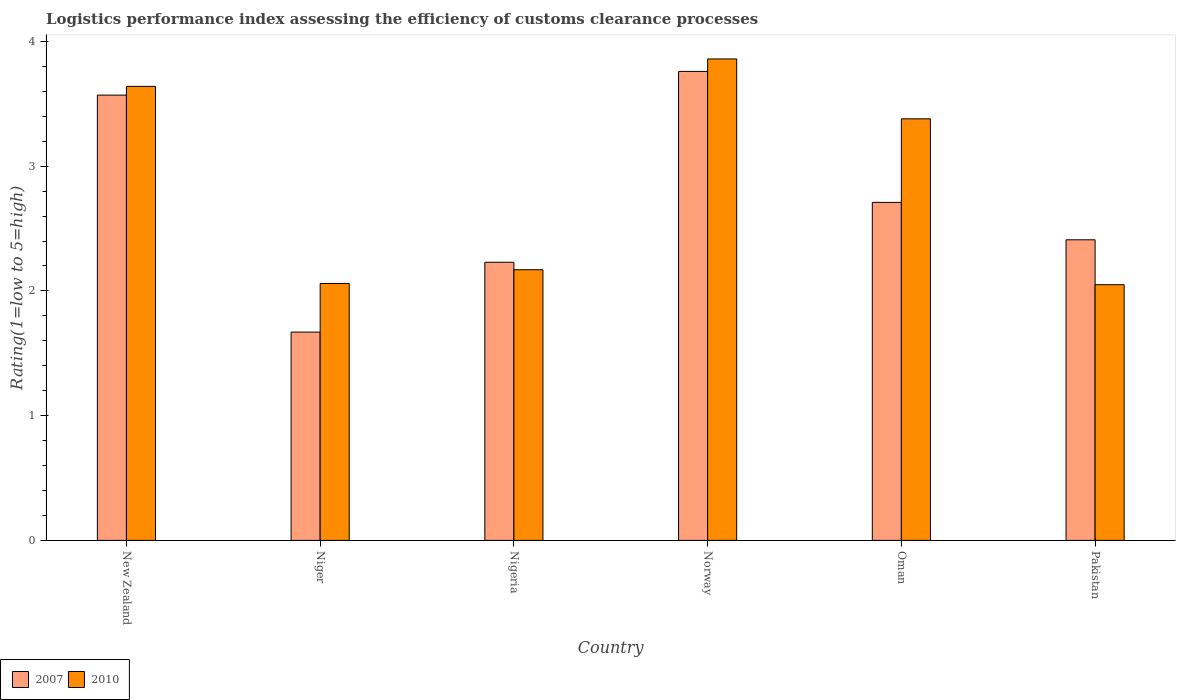How many different coloured bars are there?
Your response must be concise. 2. How many groups of bars are there?
Your answer should be compact. 6. Are the number of bars on each tick of the X-axis equal?
Your answer should be very brief. Yes. How many bars are there on the 3rd tick from the left?
Offer a terse response. 2. What is the Logistic performance index in 2010 in Norway?
Ensure brevity in your answer.  3.86. Across all countries, what is the maximum Logistic performance index in 2010?
Provide a succinct answer. 3.86. Across all countries, what is the minimum Logistic performance index in 2010?
Make the answer very short. 2.05. In which country was the Logistic performance index in 2010 minimum?
Offer a very short reply. Pakistan. What is the total Logistic performance index in 2010 in the graph?
Your response must be concise. 17.16. What is the difference between the Logistic performance index in 2007 in Norway and that in Oman?
Your answer should be compact. 1.05. What is the difference between the Logistic performance index in 2010 in Oman and the Logistic performance index in 2007 in Niger?
Provide a succinct answer. 1.71. What is the average Logistic performance index in 2010 per country?
Ensure brevity in your answer.  2.86. What is the difference between the Logistic performance index of/in 2010 and Logistic performance index of/in 2007 in Pakistan?
Your response must be concise. -0.36. What is the ratio of the Logistic performance index in 2010 in Norway to that in Oman?
Keep it short and to the point. 1.14. Is the Logistic performance index in 2007 in New Zealand less than that in Nigeria?
Offer a terse response. No. Is the difference between the Logistic performance index in 2010 in Oman and Pakistan greater than the difference between the Logistic performance index in 2007 in Oman and Pakistan?
Keep it short and to the point. Yes. What is the difference between the highest and the second highest Logistic performance index in 2010?
Give a very brief answer. -0.22. What is the difference between the highest and the lowest Logistic performance index in 2007?
Your response must be concise. 2.09. In how many countries, is the Logistic performance index in 2010 greater than the average Logistic performance index in 2010 taken over all countries?
Your response must be concise. 3. Is the sum of the Logistic performance index in 2010 in Niger and Oman greater than the maximum Logistic performance index in 2007 across all countries?
Make the answer very short. Yes. How many countries are there in the graph?
Provide a short and direct response. 6. What is the difference between two consecutive major ticks on the Y-axis?
Make the answer very short. 1. Are the values on the major ticks of Y-axis written in scientific E-notation?
Offer a very short reply. No. Does the graph contain any zero values?
Give a very brief answer. No. Does the graph contain grids?
Ensure brevity in your answer.  No. Where does the legend appear in the graph?
Make the answer very short. Bottom left. How many legend labels are there?
Make the answer very short. 2. How are the legend labels stacked?
Make the answer very short. Horizontal. What is the title of the graph?
Provide a succinct answer. Logistics performance index assessing the efficiency of customs clearance processes. Does "2009" appear as one of the legend labels in the graph?
Your response must be concise. No. What is the label or title of the Y-axis?
Give a very brief answer. Rating(1=low to 5=high). What is the Rating(1=low to 5=high) in 2007 in New Zealand?
Offer a very short reply. 3.57. What is the Rating(1=low to 5=high) of 2010 in New Zealand?
Keep it short and to the point. 3.64. What is the Rating(1=low to 5=high) in 2007 in Niger?
Give a very brief answer. 1.67. What is the Rating(1=low to 5=high) of 2010 in Niger?
Provide a short and direct response. 2.06. What is the Rating(1=low to 5=high) of 2007 in Nigeria?
Your response must be concise. 2.23. What is the Rating(1=low to 5=high) of 2010 in Nigeria?
Give a very brief answer. 2.17. What is the Rating(1=low to 5=high) of 2007 in Norway?
Offer a very short reply. 3.76. What is the Rating(1=low to 5=high) in 2010 in Norway?
Provide a short and direct response. 3.86. What is the Rating(1=low to 5=high) of 2007 in Oman?
Offer a terse response. 2.71. What is the Rating(1=low to 5=high) of 2010 in Oman?
Give a very brief answer. 3.38. What is the Rating(1=low to 5=high) in 2007 in Pakistan?
Offer a terse response. 2.41. What is the Rating(1=low to 5=high) in 2010 in Pakistan?
Your answer should be compact. 2.05. Across all countries, what is the maximum Rating(1=low to 5=high) of 2007?
Provide a short and direct response. 3.76. Across all countries, what is the maximum Rating(1=low to 5=high) of 2010?
Provide a short and direct response. 3.86. Across all countries, what is the minimum Rating(1=low to 5=high) in 2007?
Make the answer very short. 1.67. Across all countries, what is the minimum Rating(1=low to 5=high) of 2010?
Provide a short and direct response. 2.05. What is the total Rating(1=low to 5=high) in 2007 in the graph?
Ensure brevity in your answer.  16.35. What is the total Rating(1=low to 5=high) in 2010 in the graph?
Provide a succinct answer. 17.16. What is the difference between the Rating(1=low to 5=high) of 2007 in New Zealand and that in Niger?
Keep it short and to the point. 1.9. What is the difference between the Rating(1=low to 5=high) of 2010 in New Zealand and that in Niger?
Your response must be concise. 1.58. What is the difference between the Rating(1=low to 5=high) of 2007 in New Zealand and that in Nigeria?
Make the answer very short. 1.34. What is the difference between the Rating(1=low to 5=high) in 2010 in New Zealand and that in Nigeria?
Keep it short and to the point. 1.47. What is the difference between the Rating(1=low to 5=high) in 2007 in New Zealand and that in Norway?
Offer a terse response. -0.19. What is the difference between the Rating(1=low to 5=high) in 2010 in New Zealand and that in Norway?
Your answer should be compact. -0.22. What is the difference between the Rating(1=low to 5=high) in 2007 in New Zealand and that in Oman?
Your response must be concise. 0.86. What is the difference between the Rating(1=low to 5=high) of 2010 in New Zealand and that in Oman?
Give a very brief answer. 0.26. What is the difference between the Rating(1=low to 5=high) in 2007 in New Zealand and that in Pakistan?
Offer a terse response. 1.16. What is the difference between the Rating(1=low to 5=high) in 2010 in New Zealand and that in Pakistan?
Your answer should be compact. 1.59. What is the difference between the Rating(1=low to 5=high) of 2007 in Niger and that in Nigeria?
Your response must be concise. -0.56. What is the difference between the Rating(1=low to 5=high) of 2010 in Niger and that in Nigeria?
Keep it short and to the point. -0.11. What is the difference between the Rating(1=low to 5=high) in 2007 in Niger and that in Norway?
Your response must be concise. -2.09. What is the difference between the Rating(1=low to 5=high) in 2007 in Niger and that in Oman?
Make the answer very short. -1.04. What is the difference between the Rating(1=low to 5=high) of 2010 in Niger and that in Oman?
Offer a very short reply. -1.32. What is the difference between the Rating(1=low to 5=high) of 2007 in Niger and that in Pakistan?
Keep it short and to the point. -0.74. What is the difference between the Rating(1=low to 5=high) in 2010 in Niger and that in Pakistan?
Your response must be concise. 0.01. What is the difference between the Rating(1=low to 5=high) in 2007 in Nigeria and that in Norway?
Provide a short and direct response. -1.53. What is the difference between the Rating(1=low to 5=high) of 2010 in Nigeria and that in Norway?
Your answer should be compact. -1.69. What is the difference between the Rating(1=low to 5=high) in 2007 in Nigeria and that in Oman?
Offer a very short reply. -0.48. What is the difference between the Rating(1=low to 5=high) in 2010 in Nigeria and that in Oman?
Your answer should be very brief. -1.21. What is the difference between the Rating(1=low to 5=high) in 2007 in Nigeria and that in Pakistan?
Your answer should be very brief. -0.18. What is the difference between the Rating(1=low to 5=high) in 2010 in Nigeria and that in Pakistan?
Your answer should be compact. 0.12. What is the difference between the Rating(1=low to 5=high) in 2010 in Norway and that in Oman?
Your answer should be very brief. 0.48. What is the difference between the Rating(1=low to 5=high) of 2007 in Norway and that in Pakistan?
Ensure brevity in your answer.  1.35. What is the difference between the Rating(1=low to 5=high) in 2010 in Norway and that in Pakistan?
Provide a succinct answer. 1.81. What is the difference between the Rating(1=low to 5=high) in 2010 in Oman and that in Pakistan?
Provide a succinct answer. 1.33. What is the difference between the Rating(1=low to 5=high) of 2007 in New Zealand and the Rating(1=low to 5=high) of 2010 in Niger?
Your response must be concise. 1.51. What is the difference between the Rating(1=low to 5=high) of 2007 in New Zealand and the Rating(1=low to 5=high) of 2010 in Nigeria?
Your answer should be compact. 1.4. What is the difference between the Rating(1=low to 5=high) of 2007 in New Zealand and the Rating(1=low to 5=high) of 2010 in Norway?
Provide a succinct answer. -0.29. What is the difference between the Rating(1=low to 5=high) in 2007 in New Zealand and the Rating(1=low to 5=high) in 2010 in Oman?
Provide a short and direct response. 0.19. What is the difference between the Rating(1=low to 5=high) of 2007 in New Zealand and the Rating(1=low to 5=high) of 2010 in Pakistan?
Make the answer very short. 1.52. What is the difference between the Rating(1=low to 5=high) in 2007 in Niger and the Rating(1=low to 5=high) in 2010 in Nigeria?
Provide a short and direct response. -0.5. What is the difference between the Rating(1=low to 5=high) in 2007 in Niger and the Rating(1=low to 5=high) in 2010 in Norway?
Your response must be concise. -2.19. What is the difference between the Rating(1=low to 5=high) of 2007 in Niger and the Rating(1=low to 5=high) of 2010 in Oman?
Your response must be concise. -1.71. What is the difference between the Rating(1=low to 5=high) in 2007 in Niger and the Rating(1=low to 5=high) in 2010 in Pakistan?
Your answer should be very brief. -0.38. What is the difference between the Rating(1=low to 5=high) of 2007 in Nigeria and the Rating(1=low to 5=high) of 2010 in Norway?
Keep it short and to the point. -1.63. What is the difference between the Rating(1=low to 5=high) of 2007 in Nigeria and the Rating(1=low to 5=high) of 2010 in Oman?
Give a very brief answer. -1.15. What is the difference between the Rating(1=low to 5=high) in 2007 in Nigeria and the Rating(1=low to 5=high) in 2010 in Pakistan?
Offer a very short reply. 0.18. What is the difference between the Rating(1=low to 5=high) in 2007 in Norway and the Rating(1=low to 5=high) in 2010 in Oman?
Keep it short and to the point. 0.38. What is the difference between the Rating(1=low to 5=high) in 2007 in Norway and the Rating(1=low to 5=high) in 2010 in Pakistan?
Offer a terse response. 1.71. What is the difference between the Rating(1=low to 5=high) in 2007 in Oman and the Rating(1=low to 5=high) in 2010 in Pakistan?
Ensure brevity in your answer.  0.66. What is the average Rating(1=low to 5=high) in 2007 per country?
Keep it short and to the point. 2.73. What is the average Rating(1=low to 5=high) of 2010 per country?
Offer a very short reply. 2.86. What is the difference between the Rating(1=low to 5=high) of 2007 and Rating(1=low to 5=high) of 2010 in New Zealand?
Provide a succinct answer. -0.07. What is the difference between the Rating(1=low to 5=high) in 2007 and Rating(1=low to 5=high) in 2010 in Niger?
Your answer should be very brief. -0.39. What is the difference between the Rating(1=low to 5=high) in 2007 and Rating(1=low to 5=high) in 2010 in Nigeria?
Provide a succinct answer. 0.06. What is the difference between the Rating(1=low to 5=high) of 2007 and Rating(1=low to 5=high) of 2010 in Oman?
Offer a very short reply. -0.67. What is the difference between the Rating(1=low to 5=high) in 2007 and Rating(1=low to 5=high) in 2010 in Pakistan?
Ensure brevity in your answer.  0.36. What is the ratio of the Rating(1=low to 5=high) in 2007 in New Zealand to that in Niger?
Keep it short and to the point. 2.14. What is the ratio of the Rating(1=low to 5=high) in 2010 in New Zealand to that in Niger?
Keep it short and to the point. 1.77. What is the ratio of the Rating(1=low to 5=high) of 2007 in New Zealand to that in Nigeria?
Your response must be concise. 1.6. What is the ratio of the Rating(1=low to 5=high) in 2010 in New Zealand to that in Nigeria?
Your answer should be very brief. 1.68. What is the ratio of the Rating(1=low to 5=high) of 2007 in New Zealand to that in Norway?
Your response must be concise. 0.95. What is the ratio of the Rating(1=low to 5=high) in 2010 in New Zealand to that in Norway?
Ensure brevity in your answer.  0.94. What is the ratio of the Rating(1=low to 5=high) in 2007 in New Zealand to that in Oman?
Your answer should be compact. 1.32. What is the ratio of the Rating(1=low to 5=high) of 2010 in New Zealand to that in Oman?
Offer a very short reply. 1.08. What is the ratio of the Rating(1=low to 5=high) of 2007 in New Zealand to that in Pakistan?
Make the answer very short. 1.48. What is the ratio of the Rating(1=low to 5=high) of 2010 in New Zealand to that in Pakistan?
Provide a short and direct response. 1.78. What is the ratio of the Rating(1=low to 5=high) of 2007 in Niger to that in Nigeria?
Give a very brief answer. 0.75. What is the ratio of the Rating(1=low to 5=high) in 2010 in Niger to that in Nigeria?
Provide a succinct answer. 0.95. What is the ratio of the Rating(1=low to 5=high) in 2007 in Niger to that in Norway?
Offer a terse response. 0.44. What is the ratio of the Rating(1=low to 5=high) in 2010 in Niger to that in Norway?
Your answer should be very brief. 0.53. What is the ratio of the Rating(1=low to 5=high) in 2007 in Niger to that in Oman?
Give a very brief answer. 0.62. What is the ratio of the Rating(1=low to 5=high) in 2010 in Niger to that in Oman?
Make the answer very short. 0.61. What is the ratio of the Rating(1=low to 5=high) of 2007 in Niger to that in Pakistan?
Your answer should be compact. 0.69. What is the ratio of the Rating(1=low to 5=high) in 2007 in Nigeria to that in Norway?
Your response must be concise. 0.59. What is the ratio of the Rating(1=low to 5=high) of 2010 in Nigeria to that in Norway?
Make the answer very short. 0.56. What is the ratio of the Rating(1=low to 5=high) in 2007 in Nigeria to that in Oman?
Make the answer very short. 0.82. What is the ratio of the Rating(1=low to 5=high) in 2010 in Nigeria to that in Oman?
Your answer should be compact. 0.64. What is the ratio of the Rating(1=low to 5=high) in 2007 in Nigeria to that in Pakistan?
Give a very brief answer. 0.93. What is the ratio of the Rating(1=low to 5=high) of 2010 in Nigeria to that in Pakistan?
Give a very brief answer. 1.06. What is the ratio of the Rating(1=low to 5=high) of 2007 in Norway to that in Oman?
Your answer should be very brief. 1.39. What is the ratio of the Rating(1=low to 5=high) in 2010 in Norway to that in Oman?
Ensure brevity in your answer.  1.14. What is the ratio of the Rating(1=low to 5=high) of 2007 in Norway to that in Pakistan?
Offer a very short reply. 1.56. What is the ratio of the Rating(1=low to 5=high) of 2010 in Norway to that in Pakistan?
Give a very brief answer. 1.88. What is the ratio of the Rating(1=low to 5=high) of 2007 in Oman to that in Pakistan?
Make the answer very short. 1.12. What is the ratio of the Rating(1=low to 5=high) in 2010 in Oman to that in Pakistan?
Offer a terse response. 1.65. What is the difference between the highest and the second highest Rating(1=low to 5=high) of 2007?
Your answer should be very brief. 0.19. What is the difference between the highest and the second highest Rating(1=low to 5=high) of 2010?
Your response must be concise. 0.22. What is the difference between the highest and the lowest Rating(1=low to 5=high) in 2007?
Make the answer very short. 2.09. What is the difference between the highest and the lowest Rating(1=low to 5=high) in 2010?
Offer a very short reply. 1.81. 